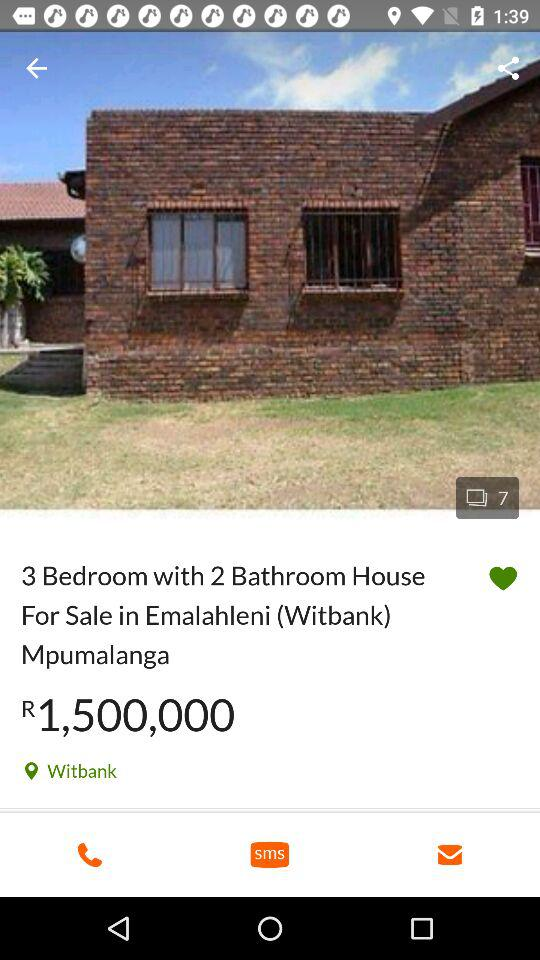How many bedrooms does the house have?
Answer the question using a single word or phrase. 3 